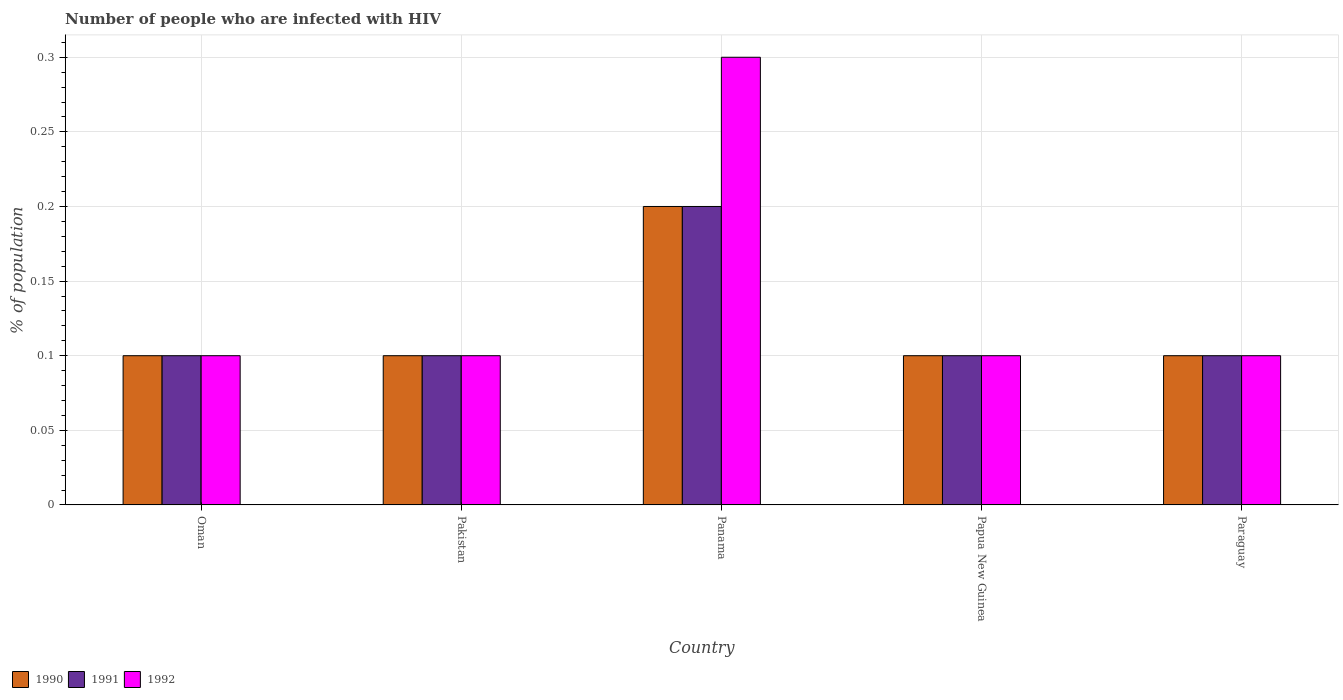How many groups of bars are there?
Give a very brief answer. 5. How many bars are there on the 5th tick from the left?
Your response must be concise. 3. How many bars are there on the 4th tick from the right?
Provide a short and direct response. 3. What is the label of the 2nd group of bars from the left?
Your response must be concise. Pakistan. What is the percentage of HIV infected population in in 1991 in Oman?
Ensure brevity in your answer.  0.1. Across all countries, what is the maximum percentage of HIV infected population in in 1992?
Offer a very short reply. 0.3. Across all countries, what is the minimum percentage of HIV infected population in in 1992?
Provide a succinct answer. 0.1. In which country was the percentage of HIV infected population in in 1991 maximum?
Your answer should be very brief. Panama. In which country was the percentage of HIV infected population in in 1991 minimum?
Provide a succinct answer. Oman. What is the difference between the percentage of HIV infected population in in 1992 in Oman and the percentage of HIV infected population in in 1991 in Panama?
Your answer should be very brief. -0.1. What is the average percentage of HIV infected population in in 1991 per country?
Offer a terse response. 0.12. What is the difference between the percentage of HIV infected population in of/in 1990 and percentage of HIV infected population in of/in 1992 in Papua New Guinea?
Give a very brief answer. 0. Is the difference between the percentage of HIV infected population in in 1990 in Oman and Pakistan greater than the difference between the percentage of HIV infected population in in 1992 in Oman and Pakistan?
Your response must be concise. No. What is the difference between the highest and the lowest percentage of HIV infected population in in 1991?
Offer a very short reply. 0.1. In how many countries, is the percentage of HIV infected population in in 1992 greater than the average percentage of HIV infected population in in 1992 taken over all countries?
Your answer should be very brief. 1. What does the 3rd bar from the right in Papua New Guinea represents?
Keep it short and to the point. 1990. What is the difference between two consecutive major ticks on the Y-axis?
Offer a very short reply. 0.05. Does the graph contain any zero values?
Ensure brevity in your answer.  No. Does the graph contain grids?
Your answer should be compact. Yes. How many legend labels are there?
Give a very brief answer. 3. What is the title of the graph?
Make the answer very short. Number of people who are infected with HIV. What is the label or title of the Y-axis?
Make the answer very short. % of population. What is the % of population in 1990 in Oman?
Ensure brevity in your answer.  0.1. What is the % of population in 1991 in Pakistan?
Give a very brief answer. 0.1. What is the % of population in 1991 in Panama?
Keep it short and to the point. 0.2. What is the % of population in 1990 in Papua New Guinea?
Keep it short and to the point. 0.1. What is the % of population of 1991 in Papua New Guinea?
Offer a very short reply. 0.1. What is the % of population of 1992 in Papua New Guinea?
Provide a short and direct response. 0.1. What is the % of population of 1990 in Paraguay?
Provide a short and direct response. 0.1. What is the % of population of 1991 in Paraguay?
Provide a succinct answer. 0.1. What is the % of population in 1992 in Paraguay?
Ensure brevity in your answer.  0.1. Across all countries, what is the minimum % of population of 1990?
Give a very brief answer. 0.1. What is the total % of population in 1992 in the graph?
Give a very brief answer. 0.7. What is the difference between the % of population in 1990 in Oman and that in Pakistan?
Ensure brevity in your answer.  0. What is the difference between the % of population of 1991 in Oman and that in Pakistan?
Offer a very short reply. 0. What is the difference between the % of population in 1991 in Oman and that in Panama?
Provide a short and direct response. -0.1. What is the difference between the % of population of 1990 in Oman and that in Papua New Guinea?
Keep it short and to the point. 0. What is the difference between the % of population of 1991 in Oman and that in Paraguay?
Provide a succinct answer. 0. What is the difference between the % of population of 1992 in Pakistan and that in Papua New Guinea?
Make the answer very short. 0. What is the difference between the % of population of 1990 in Pakistan and that in Paraguay?
Offer a very short reply. 0. What is the difference between the % of population in 1992 in Pakistan and that in Paraguay?
Ensure brevity in your answer.  0. What is the difference between the % of population in 1991 in Panama and that in Papua New Guinea?
Provide a succinct answer. 0.1. What is the difference between the % of population of 1992 in Panama and that in Papua New Guinea?
Make the answer very short. 0.2. What is the difference between the % of population in 1990 in Panama and that in Paraguay?
Make the answer very short. 0.1. What is the difference between the % of population of 1990 in Papua New Guinea and that in Paraguay?
Offer a terse response. 0. What is the difference between the % of population in 1991 in Papua New Guinea and that in Paraguay?
Provide a succinct answer. 0. What is the difference between the % of population of 1990 in Oman and the % of population of 1992 in Pakistan?
Keep it short and to the point. 0. What is the difference between the % of population in 1991 in Oman and the % of population in 1992 in Pakistan?
Give a very brief answer. 0. What is the difference between the % of population in 1990 in Oman and the % of population in 1991 in Panama?
Provide a short and direct response. -0.1. What is the difference between the % of population in 1990 in Oman and the % of population in 1991 in Papua New Guinea?
Make the answer very short. 0. What is the difference between the % of population in 1990 in Oman and the % of population in 1991 in Paraguay?
Offer a very short reply. 0. What is the difference between the % of population of 1991 in Pakistan and the % of population of 1992 in Papua New Guinea?
Ensure brevity in your answer.  0. What is the difference between the % of population in 1990 in Pakistan and the % of population in 1991 in Paraguay?
Your answer should be compact. 0. What is the difference between the % of population of 1990 in Pakistan and the % of population of 1992 in Paraguay?
Ensure brevity in your answer.  0. What is the difference between the % of population of 1991 in Pakistan and the % of population of 1992 in Paraguay?
Your answer should be compact. 0. What is the difference between the % of population of 1990 in Panama and the % of population of 1991 in Papua New Guinea?
Give a very brief answer. 0.1. What is the difference between the % of population of 1990 in Panama and the % of population of 1992 in Papua New Guinea?
Offer a very short reply. 0.1. What is the difference between the % of population of 1991 in Panama and the % of population of 1992 in Papua New Guinea?
Provide a succinct answer. 0.1. What is the difference between the % of population of 1990 in Panama and the % of population of 1991 in Paraguay?
Your answer should be compact. 0.1. What is the difference between the % of population of 1990 in Papua New Guinea and the % of population of 1992 in Paraguay?
Provide a short and direct response. 0. What is the average % of population of 1990 per country?
Your response must be concise. 0.12. What is the average % of population in 1991 per country?
Ensure brevity in your answer.  0.12. What is the average % of population of 1992 per country?
Provide a succinct answer. 0.14. What is the difference between the % of population of 1990 and % of population of 1992 in Panama?
Give a very brief answer. -0.1. What is the difference between the % of population of 1990 and % of population of 1992 in Papua New Guinea?
Provide a succinct answer. 0. What is the difference between the % of population in 1990 and % of population in 1991 in Paraguay?
Offer a terse response. 0. What is the difference between the % of population in 1990 and % of population in 1992 in Paraguay?
Ensure brevity in your answer.  0. What is the ratio of the % of population in 1991 in Oman to that in Pakistan?
Provide a short and direct response. 1. What is the ratio of the % of population in 1990 in Oman to that in Panama?
Make the answer very short. 0.5. What is the ratio of the % of population of 1991 in Oman to that in Panama?
Offer a very short reply. 0.5. What is the ratio of the % of population in 1990 in Oman to that in Papua New Guinea?
Your answer should be very brief. 1. What is the ratio of the % of population of 1991 in Oman to that in Papua New Guinea?
Keep it short and to the point. 1. What is the ratio of the % of population in 1992 in Oman to that in Papua New Guinea?
Provide a succinct answer. 1. What is the ratio of the % of population in 1990 in Oman to that in Paraguay?
Your answer should be compact. 1. What is the ratio of the % of population in 1990 in Pakistan to that in Panama?
Make the answer very short. 0.5. What is the ratio of the % of population in 1992 in Pakistan to that in Panama?
Keep it short and to the point. 0.33. What is the ratio of the % of population in 1990 in Pakistan to that in Papua New Guinea?
Provide a short and direct response. 1. What is the ratio of the % of population of 1991 in Pakistan to that in Papua New Guinea?
Make the answer very short. 1. What is the ratio of the % of population of 1990 in Pakistan to that in Paraguay?
Give a very brief answer. 1. What is the ratio of the % of population in 1991 in Pakistan to that in Paraguay?
Your answer should be compact. 1. What is the ratio of the % of population in 1992 in Pakistan to that in Paraguay?
Keep it short and to the point. 1. What is the ratio of the % of population of 1991 in Panama to that in Papua New Guinea?
Make the answer very short. 2. What is the ratio of the % of population in 1990 in Panama to that in Paraguay?
Ensure brevity in your answer.  2. What is the ratio of the % of population in 1990 in Papua New Guinea to that in Paraguay?
Provide a succinct answer. 1. What is the ratio of the % of population of 1991 in Papua New Guinea to that in Paraguay?
Ensure brevity in your answer.  1. What is the difference between the highest and the second highest % of population of 1991?
Provide a succinct answer. 0.1. What is the difference between the highest and the second highest % of population in 1992?
Give a very brief answer. 0.2. What is the difference between the highest and the lowest % of population of 1990?
Make the answer very short. 0.1. 